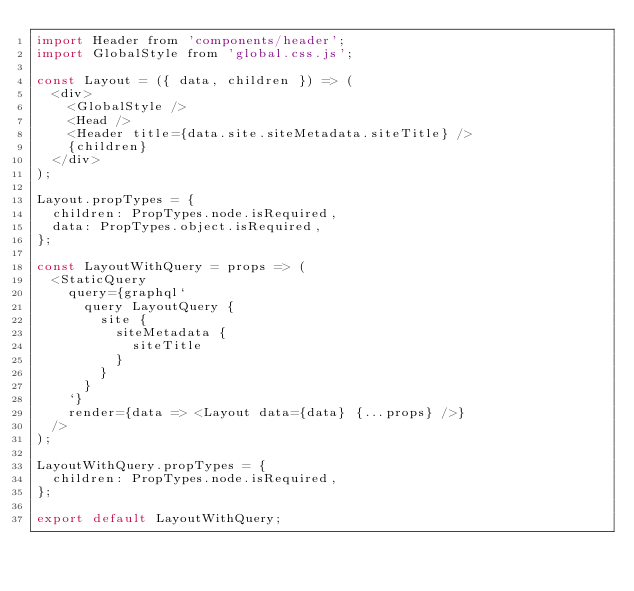Convert code to text. <code><loc_0><loc_0><loc_500><loc_500><_JavaScript_>import Header from 'components/header';
import GlobalStyle from 'global.css.js';

const Layout = ({ data, children }) => (
  <div>
    <GlobalStyle />
    <Head />
    <Header title={data.site.siteMetadata.siteTitle} />
    {children}
  </div>
);

Layout.propTypes = {
  children: PropTypes.node.isRequired,
  data: PropTypes.object.isRequired,
};

const LayoutWithQuery = props => (
  <StaticQuery
    query={graphql`
      query LayoutQuery {
        site {
          siteMetadata {
            siteTitle
          }
        }
      }
    `}
    render={data => <Layout data={data} {...props} />}
  />
);

LayoutWithQuery.propTypes = {
  children: PropTypes.node.isRequired,
};

export default LayoutWithQuery;
</code> 